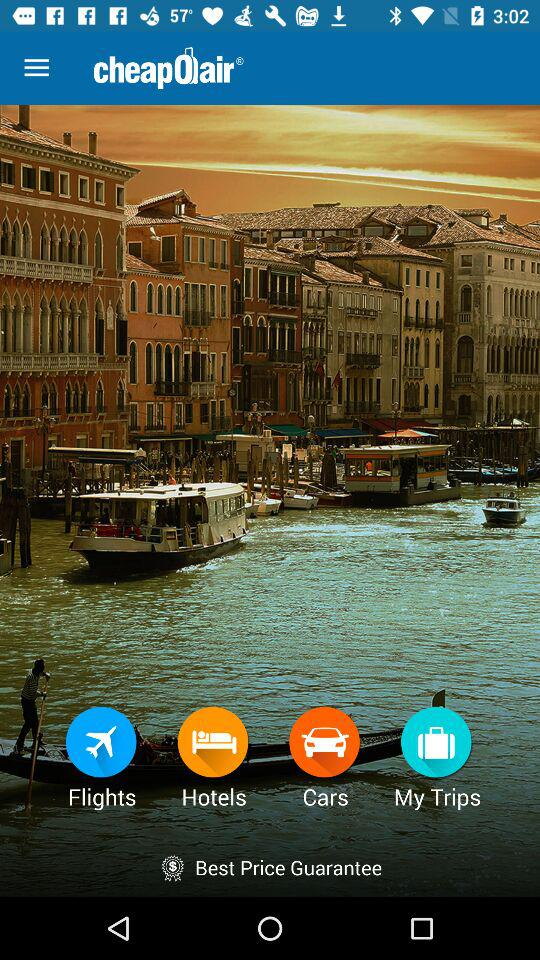What is the application name? The application name is "cheapOair". 